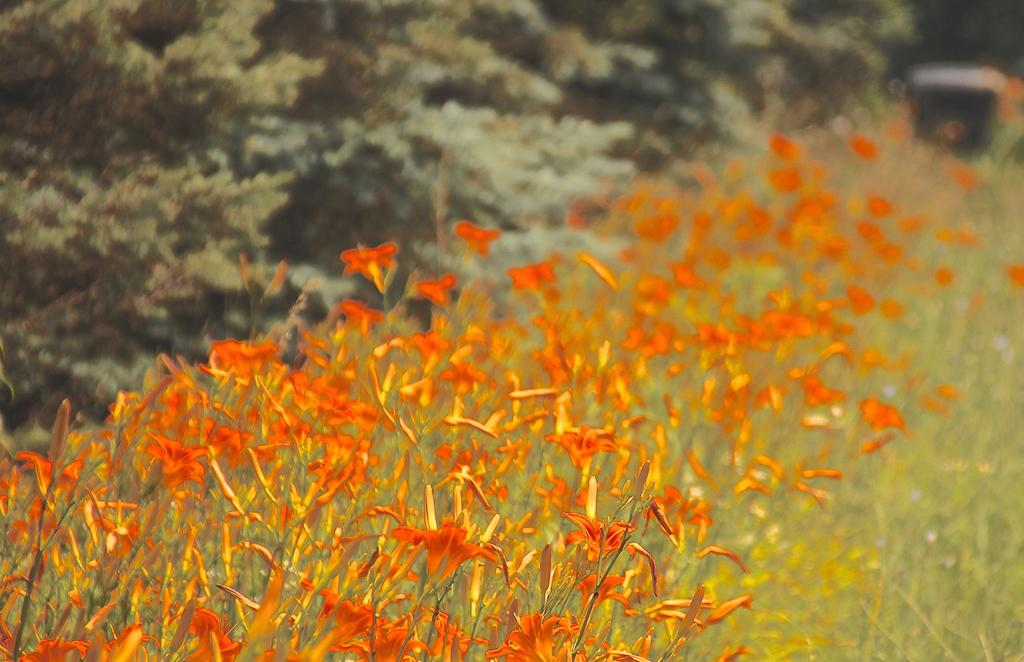What type of plants can be seen in the image? There are plants with flowers in the image. What can be seen in the background of the image? There are trees in the background of the image. Can you describe the object in the background of the image? The object in the background of the image is blurry, so it is difficult to describe its details. What songs are being sung by the plants in the image? There are no songs being sung by the plants in the image, as plants do not have the ability to sing. 